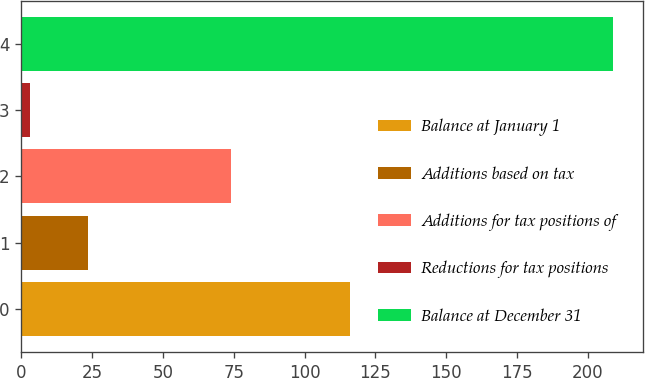Convert chart to OTSL. <chart><loc_0><loc_0><loc_500><loc_500><bar_chart><fcel>Balance at January 1<fcel>Additions based on tax<fcel>Additions for tax positions of<fcel>Reductions for tax positions<fcel>Balance at December 31<nl><fcel>116<fcel>23.6<fcel>74<fcel>3<fcel>209<nl></chart> 